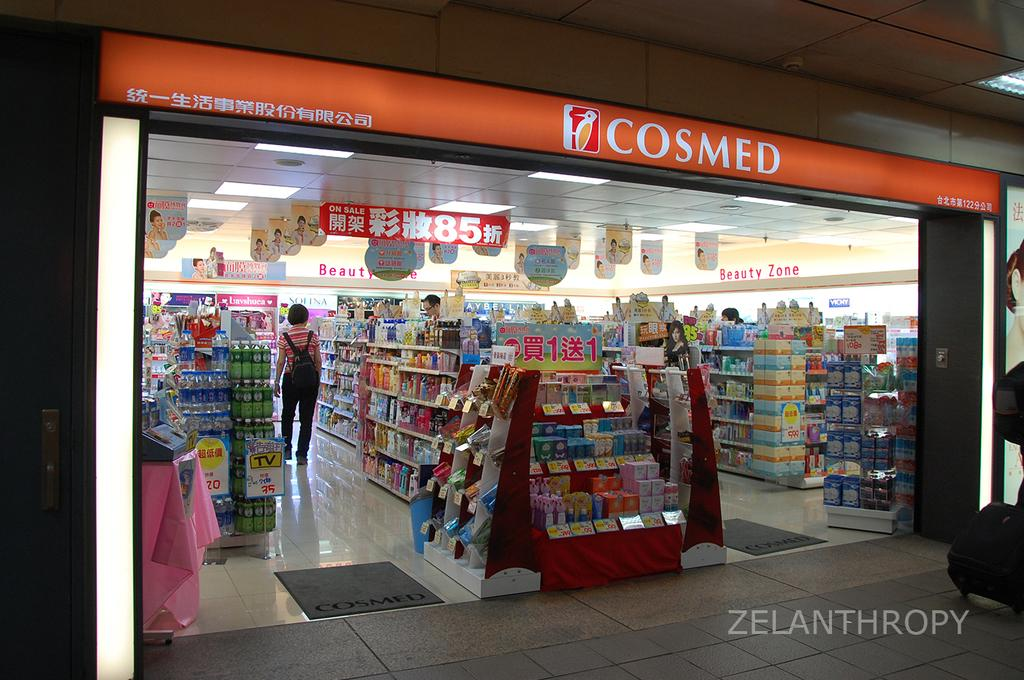Provide a one-sentence caption for the provided image. The front of a Cosmed store with many items inside of it. 